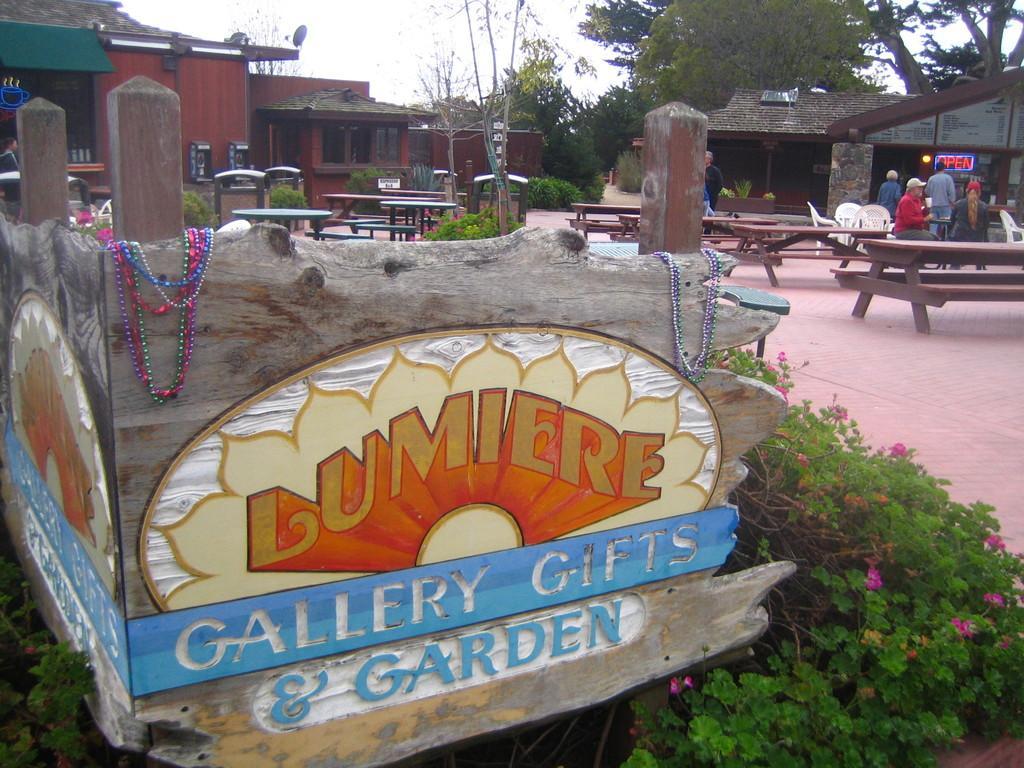Describe this image in one or two sentences. An outdoor picture. These are plants with flowers. Far there are trees. This is a building with roof top. We can able to see benches and tables. Far this persons are standing. 